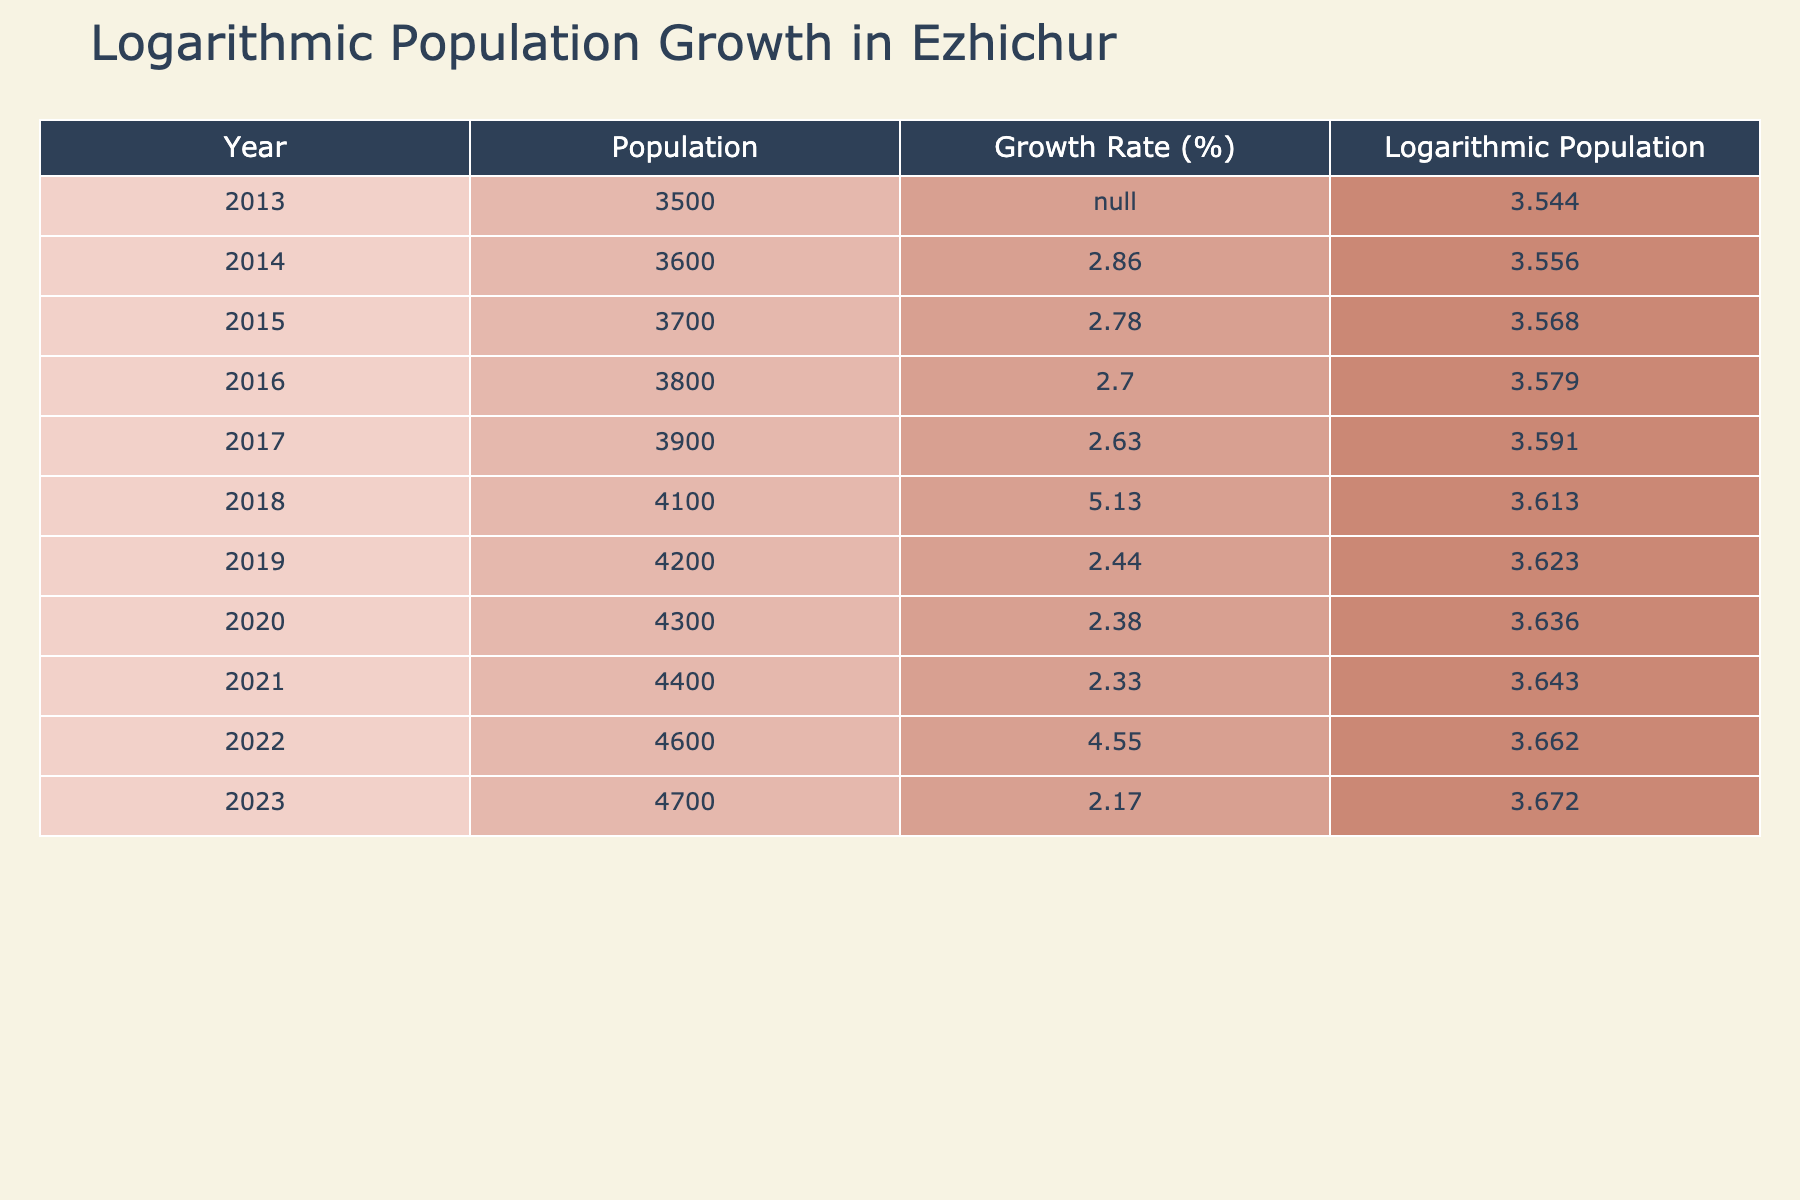What was the population of Ezhichur in 2015? In 2015, the table shows a population of 3700. I am directly retrieving this value from the corresponding row for the year 2015.
Answer: 3700 What was the growth rate in 2018? According to the table, the growth rate for the year 2018 is 5.13%. This value is directly found in the column for growth rate in the row for the year 2018.
Answer: 5.13% What is the difference in population between 2013 and 2023? To find the difference, subtract the population in 2013 (3500) from the population in 2023 (4700). Thus, the calculation is 4700 - 3500 = 1200.
Answer: 1200 Is the growth rate declining from 2014 to 2023? To determine this, we compare the growth rates from 2014 (2.86%) to 2023 (2.17%). Since 2.17% is less than 2.86%, the growth rate has indeed declined.
Answer: Yes What is the average growth rate from 2014 to 2023? The growth rates for the years 2014 (2.86), 2015 (2.78), 2016 (2.70), 2017 (2.63), 2018 (5.13), 2019 (2.44), 2020 (2.38), 2021 (2.33), 2022 (4.55), and 2023 (2.17) are summed up (2.86 + 2.78 + 2.70 + 2.63 + 5.13 + 2.44 + 2.38 + 2.33 + 4.55 + 2.17 = 27.15), and then divide by the total number of years (10). The resulting average is 27.15/10 = 2.715%.
Answer: 2.715% In which year did Ezhichur experience the highest growth rate? By examining the growth rates listed in the table, the highest growth rate of 5.13% occurred in 2018, which can be directly found in that year’s row.
Answer: 2018 What was the logarithmic population in the year with the lowest growth rate? The year with the lowest growth rate is 2023 at 2.17%. In the same row, the table shows the logarithmic population to be 3.672. This is the corresponding value for the year 2023.
Answer: 3.672 What was the population growth trend from 2016 to 2022? The growth rates from 2016 to 2022 are 2.70%, 2.63%, 5.13%, 2.44%, 2.38%, 2.33%, and 4.55%. The trend shows an increase in 2018, but otherwise displays a fluctuating pattern with an overall increase from 3800 (2016) to 4600 (2022). The two growth rates of 5.13% and 4.55% are the notable peaks, but overall, the growth does trend upward despite fluctuations.
Answer: Fluctuating upward trend What can be inferred about the population growth in the last decade? Over the past decade, the population of Ezhichur has shown a general tendency to grow, with certain years indicating higher growth rates such as in 2018. The data suggests an overall increase, but the growth rates also vary significantly year over year indicating fluctuations in growth momentum.
Answer: General increase with fluctuations 